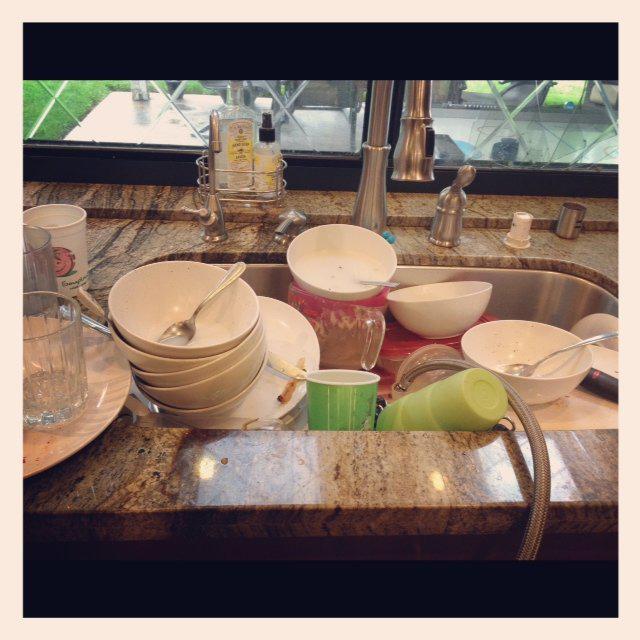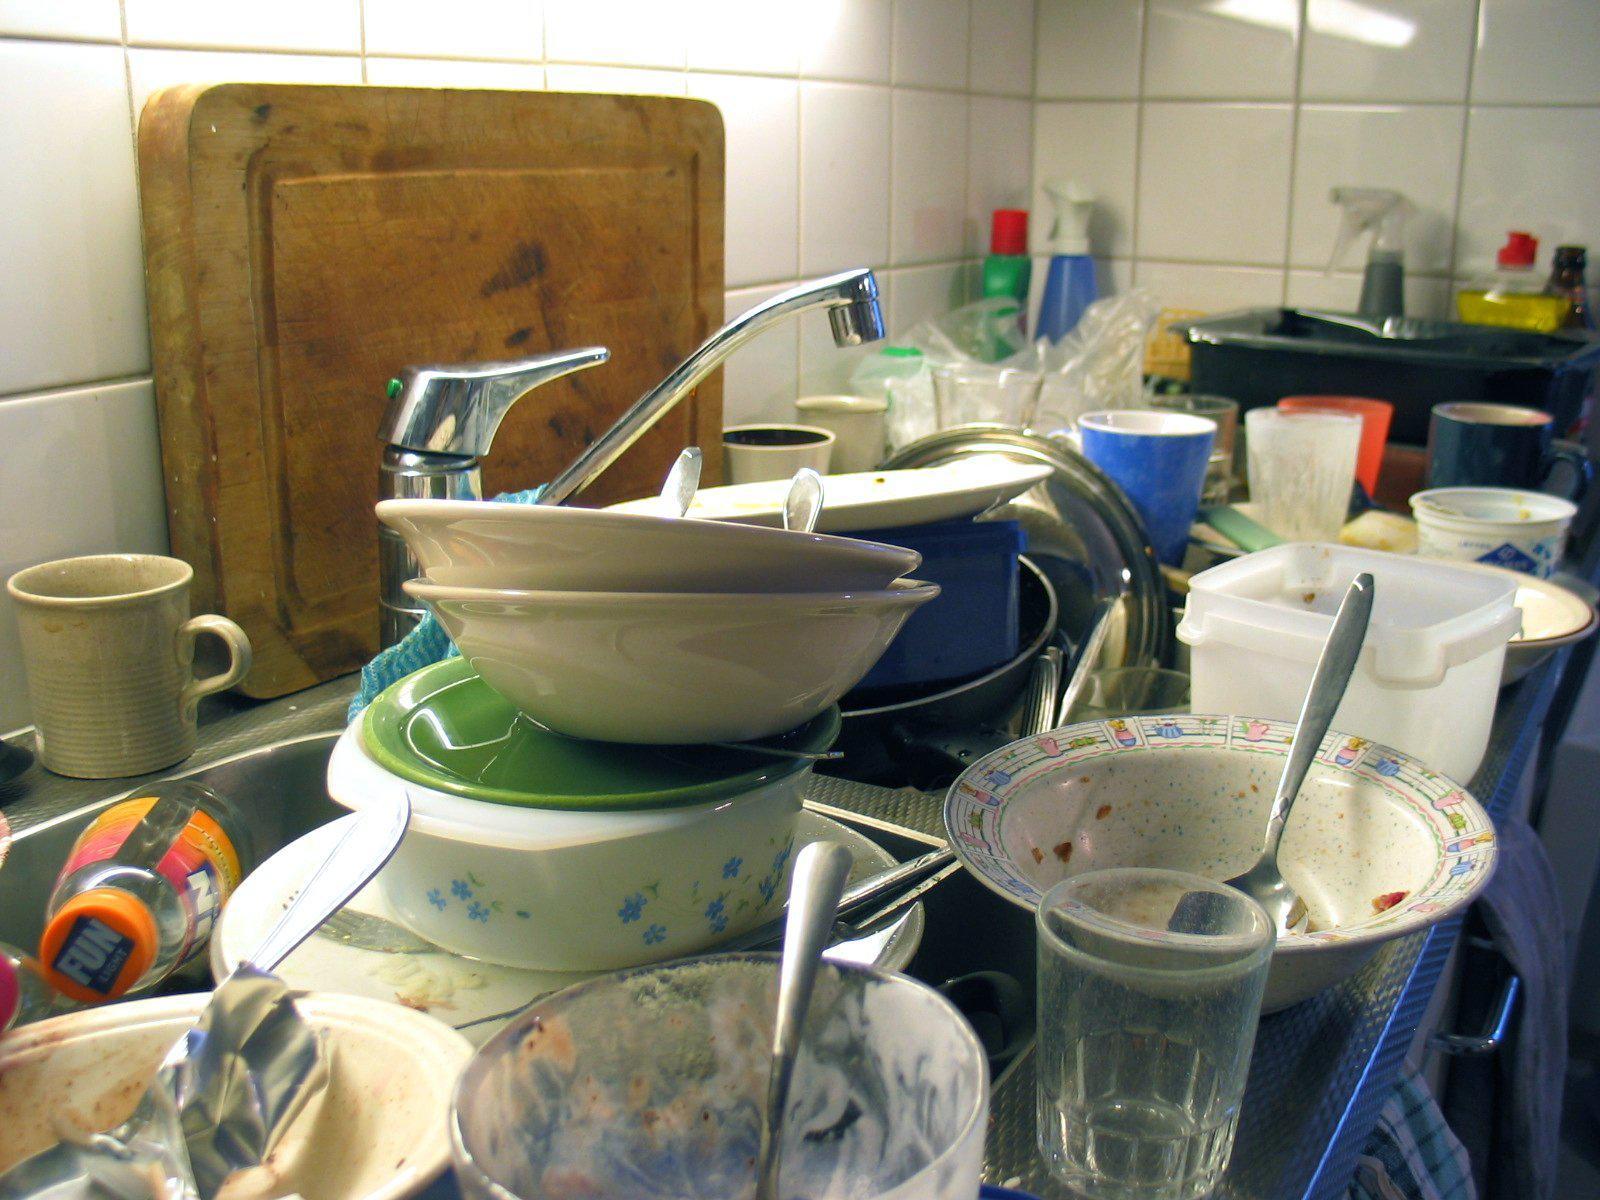The first image is the image on the left, the second image is the image on the right. Examine the images to the left and right. Is the description "At least one window is visible behind a pile of dirty dishes." accurate? Answer yes or no. Yes. The first image is the image on the left, the second image is the image on the right. For the images shown, is this caption "A big upright squarish cutting board is behind a heaping pile of dirty dishes in a sink." true? Answer yes or no. Yes. 